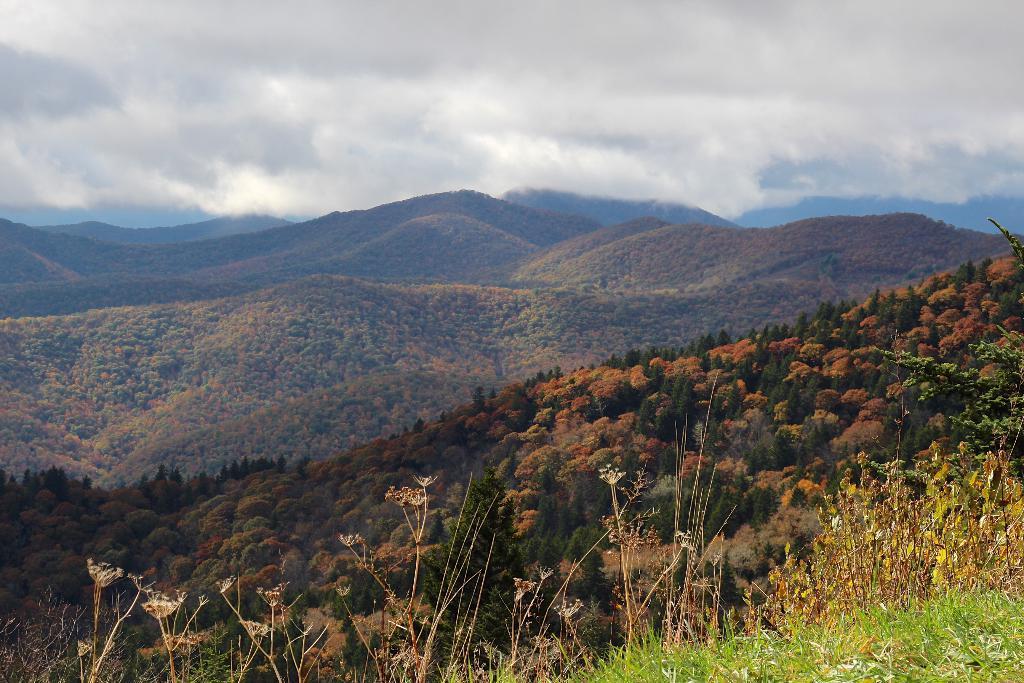Could you give a brief overview of what you see in this image? This is grass. Here we can see plants and trees. In the background we can see mountain and sky with clouds. 